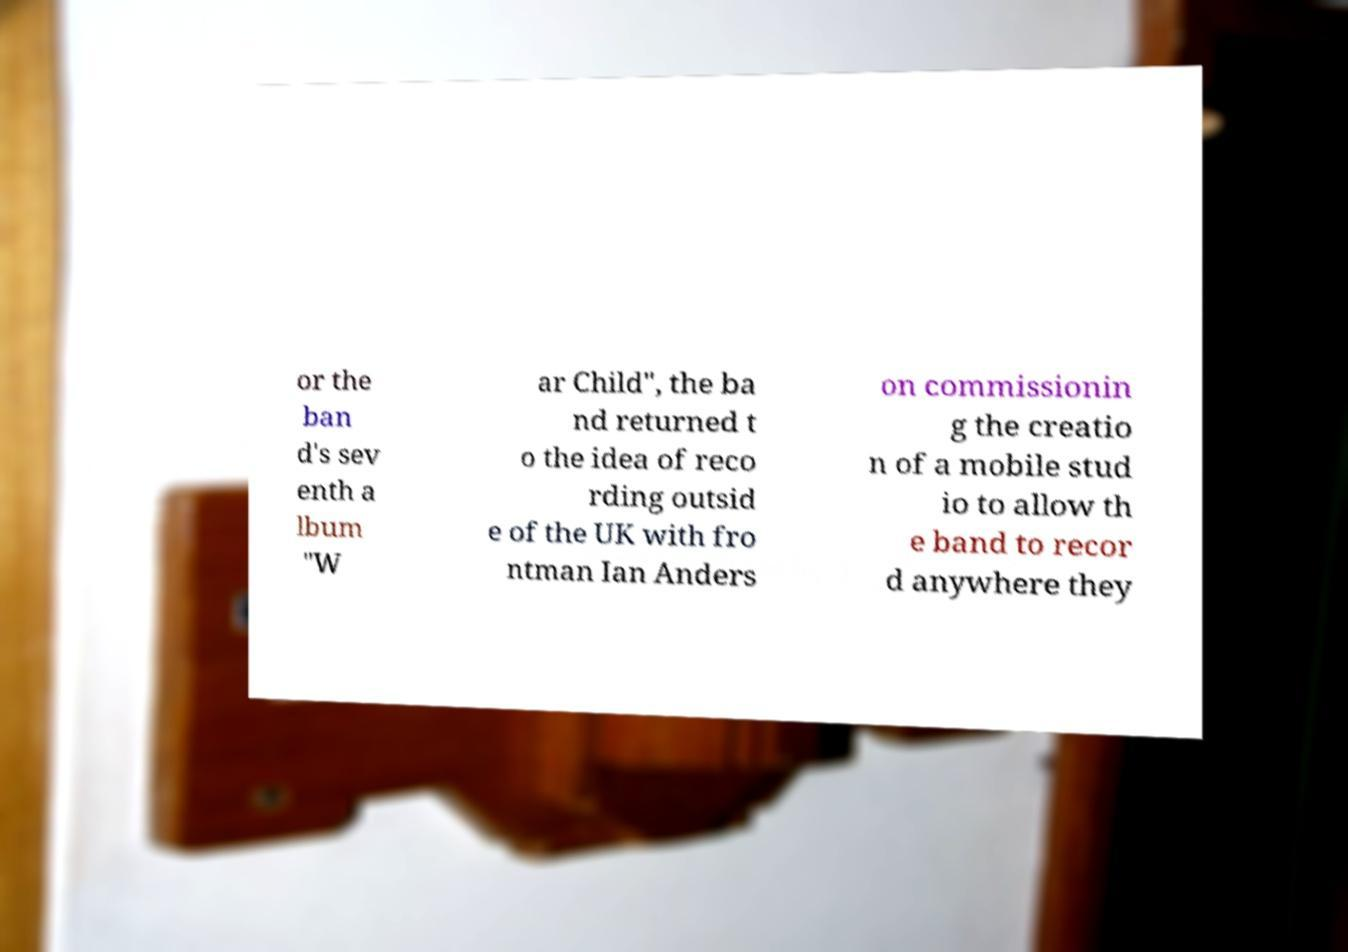There's text embedded in this image that I need extracted. Can you transcribe it verbatim? or the ban d's sev enth a lbum "W ar Child", the ba nd returned t o the idea of reco rding outsid e of the UK with fro ntman Ian Anders on commissionin g the creatio n of a mobile stud io to allow th e band to recor d anywhere they 